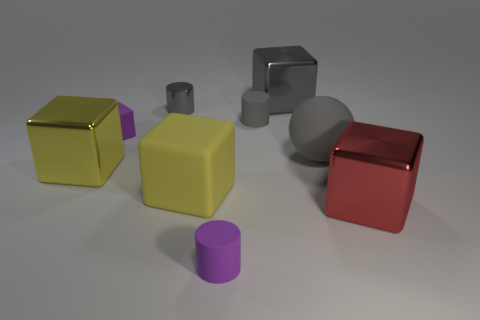Subtract all big yellow matte cubes. How many cubes are left? 4 Subtract all purple blocks. How many blocks are left? 4 Subtract all cyan blocks. Subtract all cyan cylinders. How many blocks are left? 5 Subtract all cylinders. How many objects are left? 6 Add 8 large red shiny cubes. How many large red shiny cubes exist? 9 Subtract 0 green spheres. How many objects are left? 9 Subtract all small matte things. Subtract all yellow things. How many objects are left? 4 Add 5 large yellow shiny blocks. How many large yellow shiny blocks are left? 6 